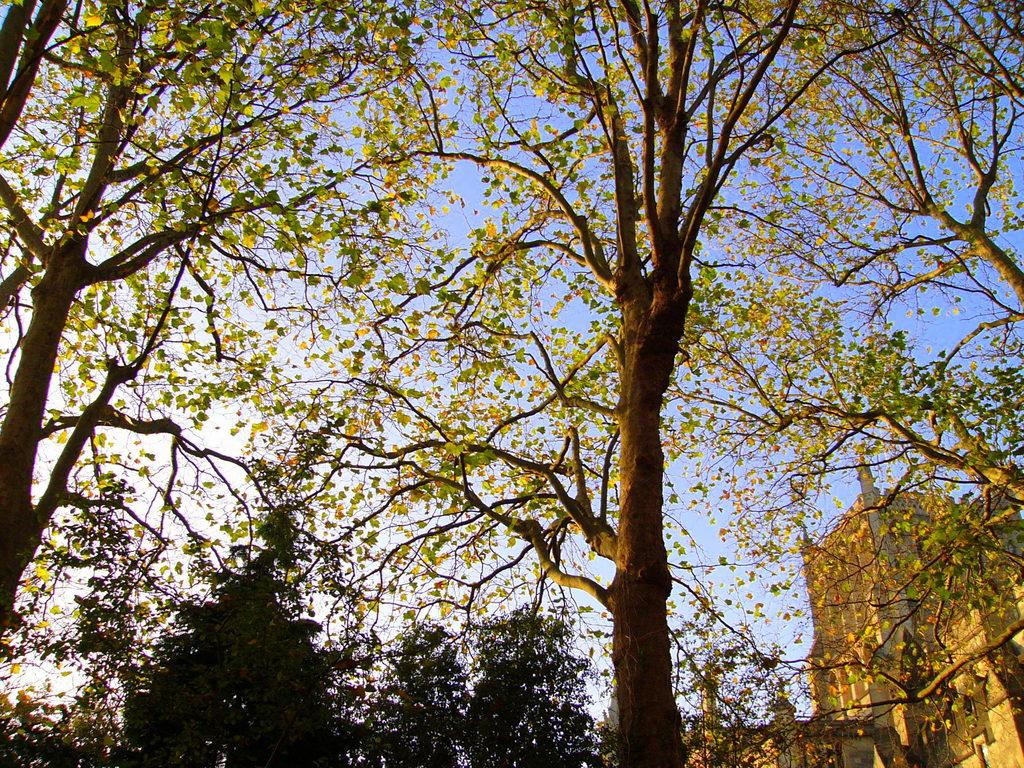What type of vegetation can be seen in the image? There are trees in the image, extending from left to right. What structure is located on the right side of the image? There is a building on the right side of the image. What type of glue is being used to hold the flag in the image? There is no flag present in the image, so there is no glue being used. 